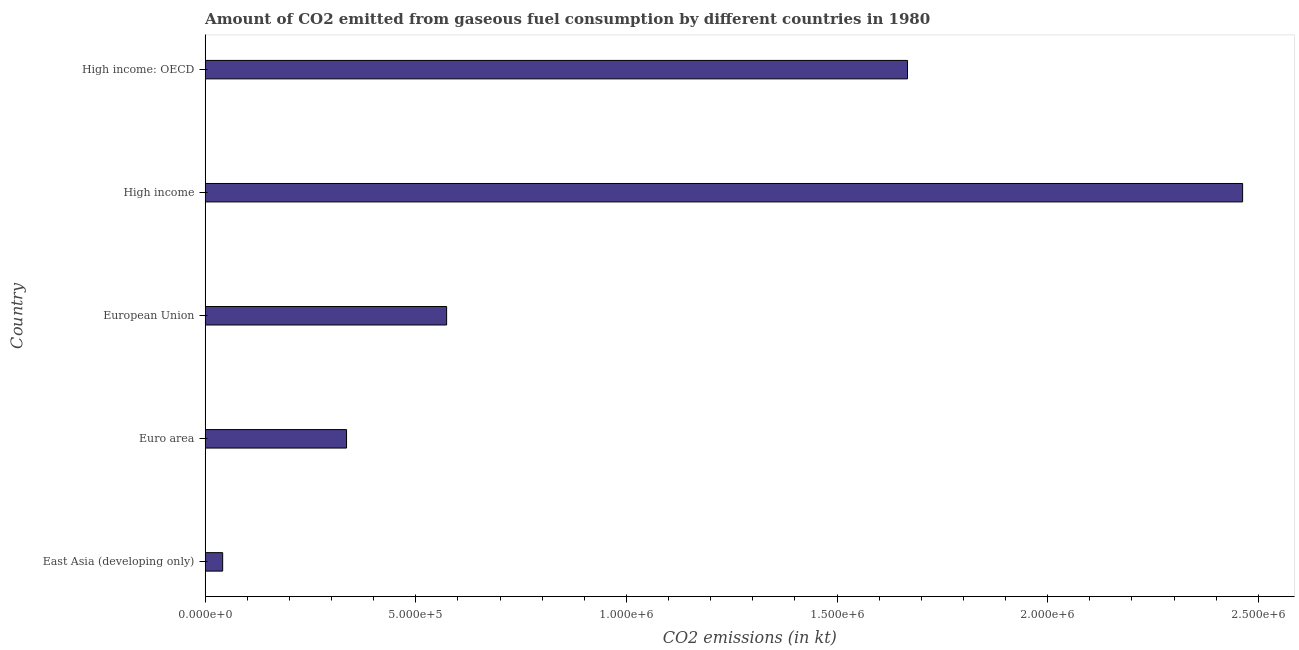Does the graph contain any zero values?
Give a very brief answer. No. Does the graph contain grids?
Make the answer very short. No. What is the title of the graph?
Give a very brief answer. Amount of CO2 emitted from gaseous fuel consumption by different countries in 1980. What is the label or title of the X-axis?
Give a very brief answer. CO2 emissions (in kt). What is the co2 emissions from gaseous fuel consumption in High income?
Ensure brevity in your answer.  2.46e+06. Across all countries, what is the maximum co2 emissions from gaseous fuel consumption?
Keep it short and to the point. 2.46e+06. Across all countries, what is the minimum co2 emissions from gaseous fuel consumption?
Keep it short and to the point. 4.15e+04. In which country was the co2 emissions from gaseous fuel consumption minimum?
Offer a terse response. East Asia (developing only). What is the sum of the co2 emissions from gaseous fuel consumption?
Your response must be concise. 5.08e+06. What is the difference between the co2 emissions from gaseous fuel consumption in High income and High income: OECD?
Ensure brevity in your answer.  7.95e+05. What is the average co2 emissions from gaseous fuel consumption per country?
Provide a succinct answer. 1.02e+06. What is the median co2 emissions from gaseous fuel consumption?
Offer a very short reply. 5.73e+05. In how many countries, is the co2 emissions from gaseous fuel consumption greater than 500000 kt?
Offer a terse response. 3. What is the ratio of the co2 emissions from gaseous fuel consumption in Euro area to that in High income?
Provide a short and direct response. 0.14. Is the co2 emissions from gaseous fuel consumption in Euro area less than that in European Union?
Make the answer very short. Yes. Is the difference between the co2 emissions from gaseous fuel consumption in East Asia (developing only) and High income: OECD greater than the difference between any two countries?
Ensure brevity in your answer.  No. What is the difference between the highest and the second highest co2 emissions from gaseous fuel consumption?
Offer a terse response. 7.95e+05. What is the difference between the highest and the lowest co2 emissions from gaseous fuel consumption?
Provide a succinct answer. 2.42e+06. In how many countries, is the co2 emissions from gaseous fuel consumption greater than the average co2 emissions from gaseous fuel consumption taken over all countries?
Make the answer very short. 2. How many bars are there?
Provide a short and direct response. 5. Are all the bars in the graph horizontal?
Your response must be concise. Yes. How many countries are there in the graph?
Keep it short and to the point. 5. What is the difference between two consecutive major ticks on the X-axis?
Your answer should be compact. 5.00e+05. What is the CO2 emissions (in kt) of East Asia (developing only)?
Provide a succinct answer. 4.15e+04. What is the CO2 emissions (in kt) of Euro area?
Your response must be concise. 3.36e+05. What is the CO2 emissions (in kt) of European Union?
Provide a short and direct response. 5.73e+05. What is the CO2 emissions (in kt) in High income?
Provide a short and direct response. 2.46e+06. What is the CO2 emissions (in kt) in High income: OECD?
Offer a very short reply. 1.67e+06. What is the difference between the CO2 emissions (in kt) in East Asia (developing only) and Euro area?
Your response must be concise. -2.94e+05. What is the difference between the CO2 emissions (in kt) in East Asia (developing only) and European Union?
Give a very brief answer. -5.32e+05. What is the difference between the CO2 emissions (in kt) in East Asia (developing only) and High income?
Your response must be concise. -2.42e+06. What is the difference between the CO2 emissions (in kt) in East Asia (developing only) and High income: OECD?
Keep it short and to the point. -1.63e+06. What is the difference between the CO2 emissions (in kt) in Euro area and European Union?
Your answer should be very brief. -2.38e+05. What is the difference between the CO2 emissions (in kt) in Euro area and High income?
Make the answer very short. -2.13e+06. What is the difference between the CO2 emissions (in kt) in Euro area and High income: OECD?
Provide a succinct answer. -1.33e+06. What is the difference between the CO2 emissions (in kt) in European Union and High income?
Provide a succinct answer. -1.89e+06. What is the difference between the CO2 emissions (in kt) in European Union and High income: OECD?
Your answer should be compact. -1.09e+06. What is the difference between the CO2 emissions (in kt) in High income and High income: OECD?
Provide a succinct answer. 7.95e+05. What is the ratio of the CO2 emissions (in kt) in East Asia (developing only) to that in Euro area?
Give a very brief answer. 0.12. What is the ratio of the CO2 emissions (in kt) in East Asia (developing only) to that in European Union?
Your answer should be very brief. 0.07. What is the ratio of the CO2 emissions (in kt) in East Asia (developing only) to that in High income?
Your answer should be very brief. 0.02. What is the ratio of the CO2 emissions (in kt) in East Asia (developing only) to that in High income: OECD?
Keep it short and to the point. 0.03. What is the ratio of the CO2 emissions (in kt) in Euro area to that in European Union?
Give a very brief answer. 0.59. What is the ratio of the CO2 emissions (in kt) in Euro area to that in High income?
Your answer should be compact. 0.14. What is the ratio of the CO2 emissions (in kt) in Euro area to that in High income: OECD?
Ensure brevity in your answer.  0.2. What is the ratio of the CO2 emissions (in kt) in European Union to that in High income?
Offer a very short reply. 0.23. What is the ratio of the CO2 emissions (in kt) in European Union to that in High income: OECD?
Ensure brevity in your answer.  0.34. What is the ratio of the CO2 emissions (in kt) in High income to that in High income: OECD?
Make the answer very short. 1.48. 